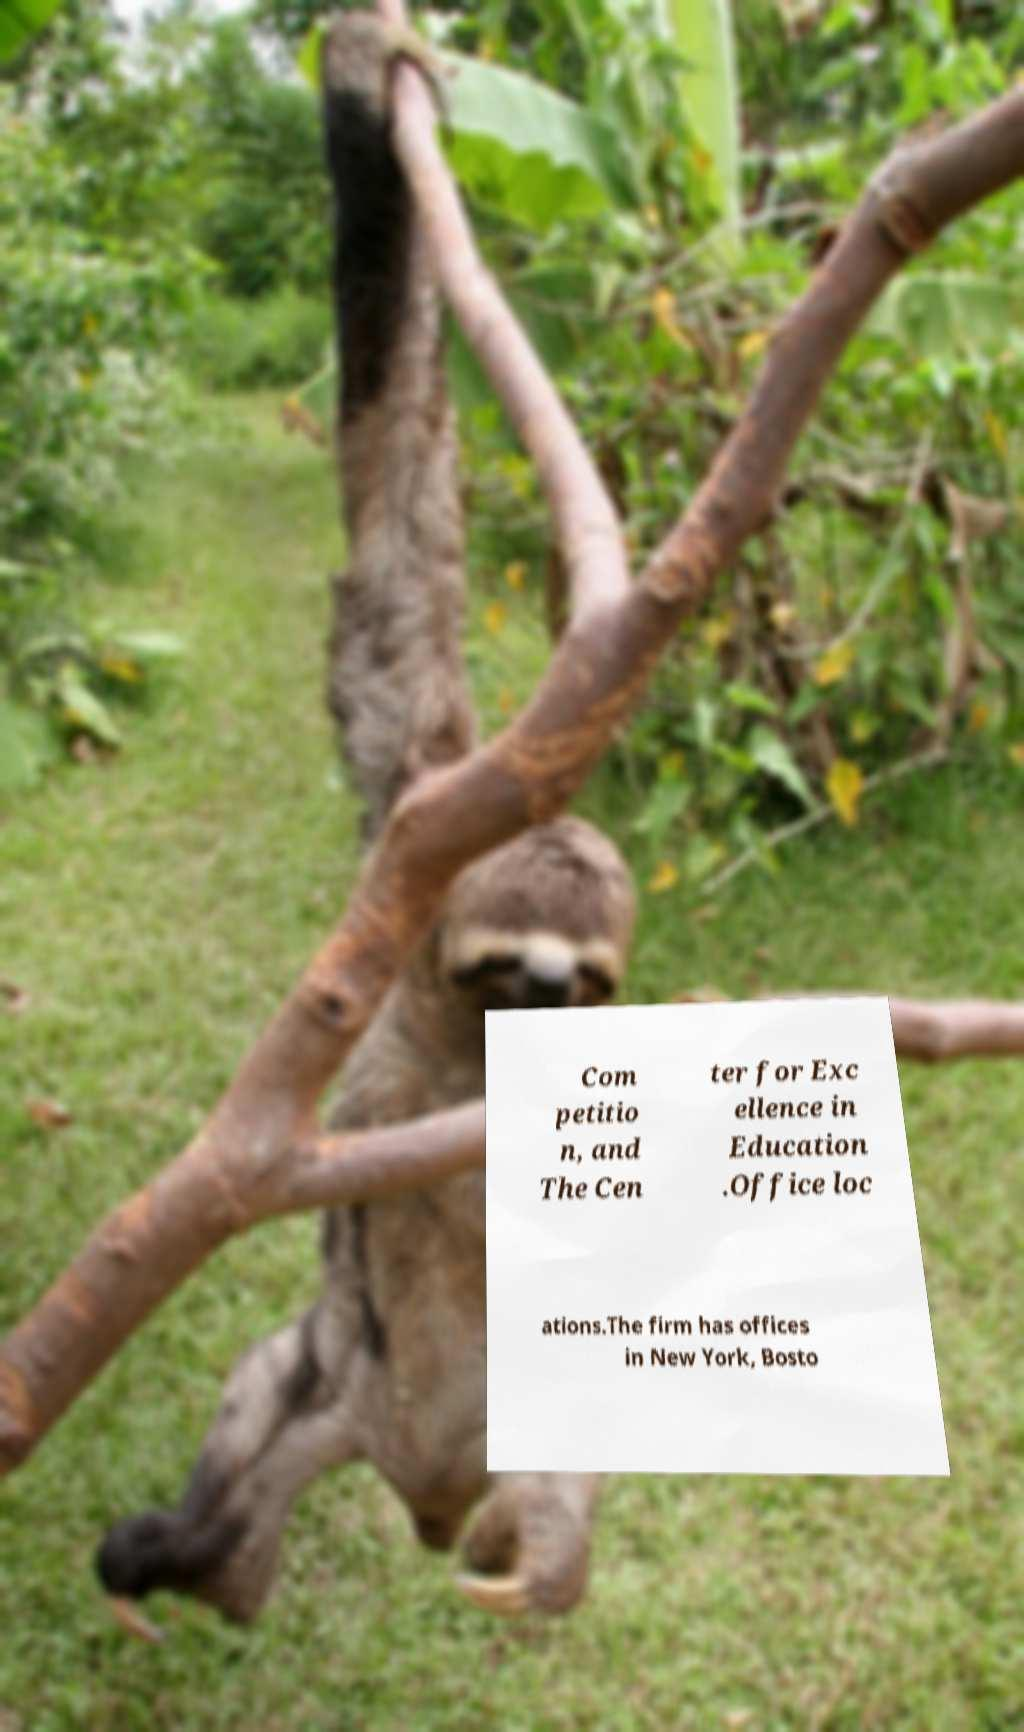Please identify and transcribe the text found in this image. Com petitio n, and The Cen ter for Exc ellence in Education .Office loc ations.The firm has offices in New York, Bosto 